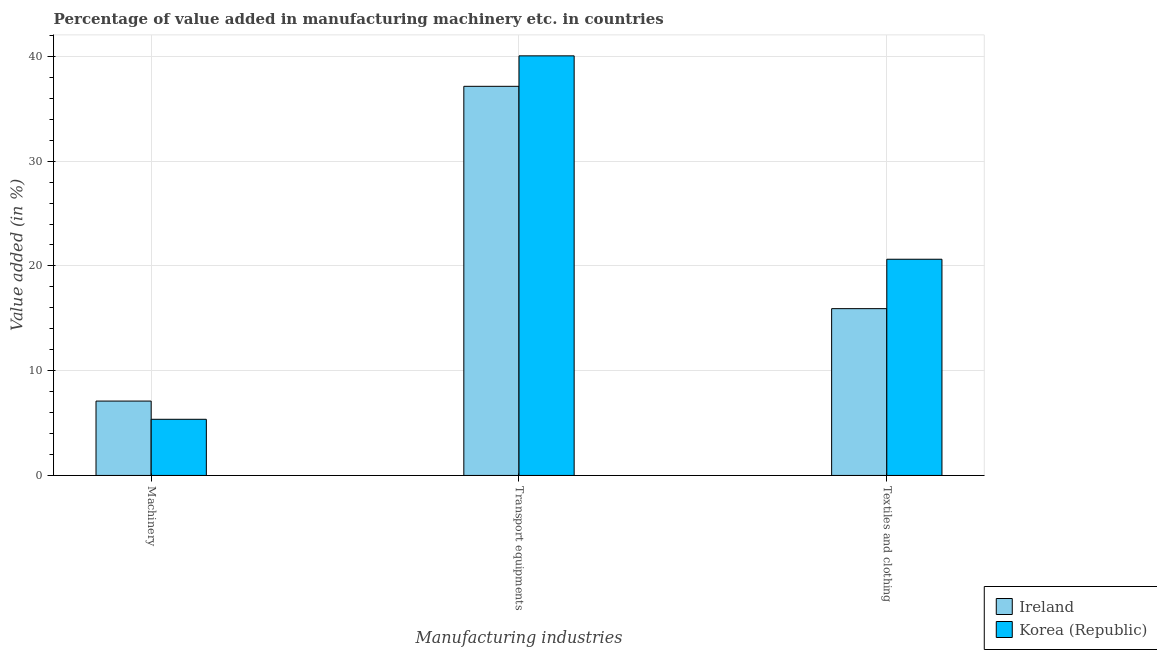How many bars are there on the 2nd tick from the right?
Your answer should be compact. 2. What is the label of the 3rd group of bars from the left?
Your answer should be compact. Textiles and clothing. What is the value added in manufacturing machinery in Korea (Republic)?
Keep it short and to the point. 5.36. Across all countries, what is the maximum value added in manufacturing textile and clothing?
Your response must be concise. 20.64. Across all countries, what is the minimum value added in manufacturing transport equipments?
Your response must be concise. 37.15. In which country was the value added in manufacturing textile and clothing maximum?
Your response must be concise. Korea (Republic). In which country was the value added in manufacturing transport equipments minimum?
Provide a succinct answer. Ireland. What is the total value added in manufacturing transport equipments in the graph?
Your response must be concise. 77.2. What is the difference between the value added in manufacturing textile and clothing in Korea (Republic) and that in Ireland?
Your answer should be very brief. 4.72. What is the difference between the value added in manufacturing transport equipments in Korea (Republic) and the value added in manufacturing textile and clothing in Ireland?
Ensure brevity in your answer.  24.13. What is the average value added in manufacturing machinery per country?
Provide a succinct answer. 6.23. What is the difference between the value added in manufacturing transport equipments and value added in manufacturing machinery in Korea (Republic)?
Make the answer very short. 34.69. What is the ratio of the value added in manufacturing textile and clothing in Korea (Republic) to that in Ireland?
Your answer should be compact. 1.3. What is the difference between the highest and the second highest value added in manufacturing machinery?
Provide a succinct answer. 1.74. What is the difference between the highest and the lowest value added in manufacturing machinery?
Make the answer very short. 1.74. What does the 1st bar from the left in Textiles and clothing represents?
Offer a very short reply. Ireland. Is it the case that in every country, the sum of the value added in manufacturing machinery and value added in manufacturing transport equipments is greater than the value added in manufacturing textile and clothing?
Ensure brevity in your answer.  Yes. Are all the bars in the graph horizontal?
Offer a terse response. No. Are the values on the major ticks of Y-axis written in scientific E-notation?
Provide a short and direct response. No. Does the graph contain any zero values?
Offer a terse response. No. How many legend labels are there?
Provide a short and direct response. 2. What is the title of the graph?
Make the answer very short. Percentage of value added in manufacturing machinery etc. in countries. What is the label or title of the X-axis?
Give a very brief answer. Manufacturing industries. What is the label or title of the Y-axis?
Provide a succinct answer. Value added (in %). What is the Value added (in %) of Ireland in Machinery?
Offer a very short reply. 7.1. What is the Value added (in %) in Korea (Republic) in Machinery?
Offer a terse response. 5.36. What is the Value added (in %) of Ireland in Transport equipments?
Offer a terse response. 37.15. What is the Value added (in %) in Korea (Republic) in Transport equipments?
Provide a succinct answer. 40.05. What is the Value added (in %) in Ireland in Textiles and clothing?
Your answer should be compact. 15.92. What is the Value added (in %) in Korea (Republic) in Textiles and clothing?
Your response must be concise. 20.64. Across all Manufacturing industries, what is the maximum Value added (in %) of Ireland?
Your response must be concise. 37.15. Across all Manufacturing industries, what is the maximum Value added (in %) in Korea (Republic)?
Your response must be concise. 40.05. Across all Manufacturing industries, what is the minimum Value added (in %) in Ireland?
Keep it short and to the point. 7.1. Across all Manufacturing industries, what is the minimum Value added (in %) in Korea (Republic)?
Offer a very short reply. 5.36. What is the total Value added (in %) of Ireland in the graph?
Your answer should be very brief. 60.17. What is the total Value added (in %) of Korea (Republic) in the graph?
Give a very brief answer. 66.05. What is the difference between the Value added (in %) of Ireland in Machinery and that in Transport equipments?
Offer a terse response. -30.05. What is the difference between the Value added (in %) of Korea (Republic) in Machinery and that in Transport equipments?
Your answer should be very brief. -34.69. What is the difference between the Value added (in %) in Ireland in Machinery and that in Textiles and clothing?
Make the answer very short. -8.82. What is the difference between the Value added (in %) of Korea (Republic) in Machinery and that in Textiles and clothing?
Give a very brief answer. -15.28. What is the difference between the Value added (in %) in Ireland in Transport equipments and that in Textiles and clothing?
Ensure brevity in your answer.  21.22. What is the difference between the Value added (in %) of Korea (Republic) in Transport equipments and that in Textiles and clothing?
Your response must be concise. 19.42. What is the difference between the Value added (in %) in Ireland in Machinery and the Value added (in %) in Korea (Republic) in Transport equipments?
Provide a succinct answer. -32.95. What is the difference between the Value added (in %) in Ireland in Machinery and the Value added (in %) in Korea (Republic) in Textiles and clothing?
Your response must be concise. -13.54. What is the difference between the Value added (in %) in Ireland in Transport equipments and the Value added (in %) in Korea (Republic) in Textiles and clothing?
Your answer should be very brief. 16.51. What is the average Value added (in %) in Ireland per Manufacturing industries?
Provide a short and direct response. 20.06. What is the average Value added (in %) of Korea (Republic) per Manufacturing industries?
Keep it short and to the point. 22.02. What is the difference between the Value added (in %) of Ireland and Value added (in %) of Korea (Republic) in Machinery?
Your answer should be compact. 1.74. What is the difference between the Value added (in %) of Ireland and Value added (in %) of Korea (Republic) in Transport equipments?
Give a very brief answer. -2.91. What is the difference between the Value added (in %) in Ireland and Value added (in %) in Korea (Republic) in Textiles and clothing?
Offer a very short reply. -4.72. What is the ratio of the Value added (in %) of Ireland in Machinery to that in Transport equipments?
Offer a terse response. 0.19. What is the ratio of the Value added (in %) in Korea (Republic) in Machinery to that in Transport equipments?
Provide a succinct answer. 0.13. What is the ratio of the Value added (in %) in Ireland in Machinery to that in Textiles and clothing?
Give a very brief answer. 0.45. What is the ratio of the Value added (in %) in Korea (Republic) in Machinery to that in Textiles and clothing?
Provide a short and direct response. 0.26. What is the ratio of the Value added (in %) of Ireland in Transport equipments to that in Textiles and clothing?
Keep it short and to the point. 2.33. What is the ratio of the Value added (in %) of Korea (Republic) in Transport equipments to that in Textiles and clothing?
Provide a succinct answer. 1.94. What is the difference between the highest and the second highest Value added (in %) of Ireland?
Offer a very short reply. 21.22. What is the difference between the highest and the second highest Value added (in %) in Korea (Republic)?
Offer a terse response. 19.42. What is the difference between the highest and the lowest Value added (in %) of Ireland?
Ensure brevity in your answer.  30.05. What is the difference between the highest and the lowest Value added (in %) of Korea (Republic)?
Offer a terse response. 34.69. 